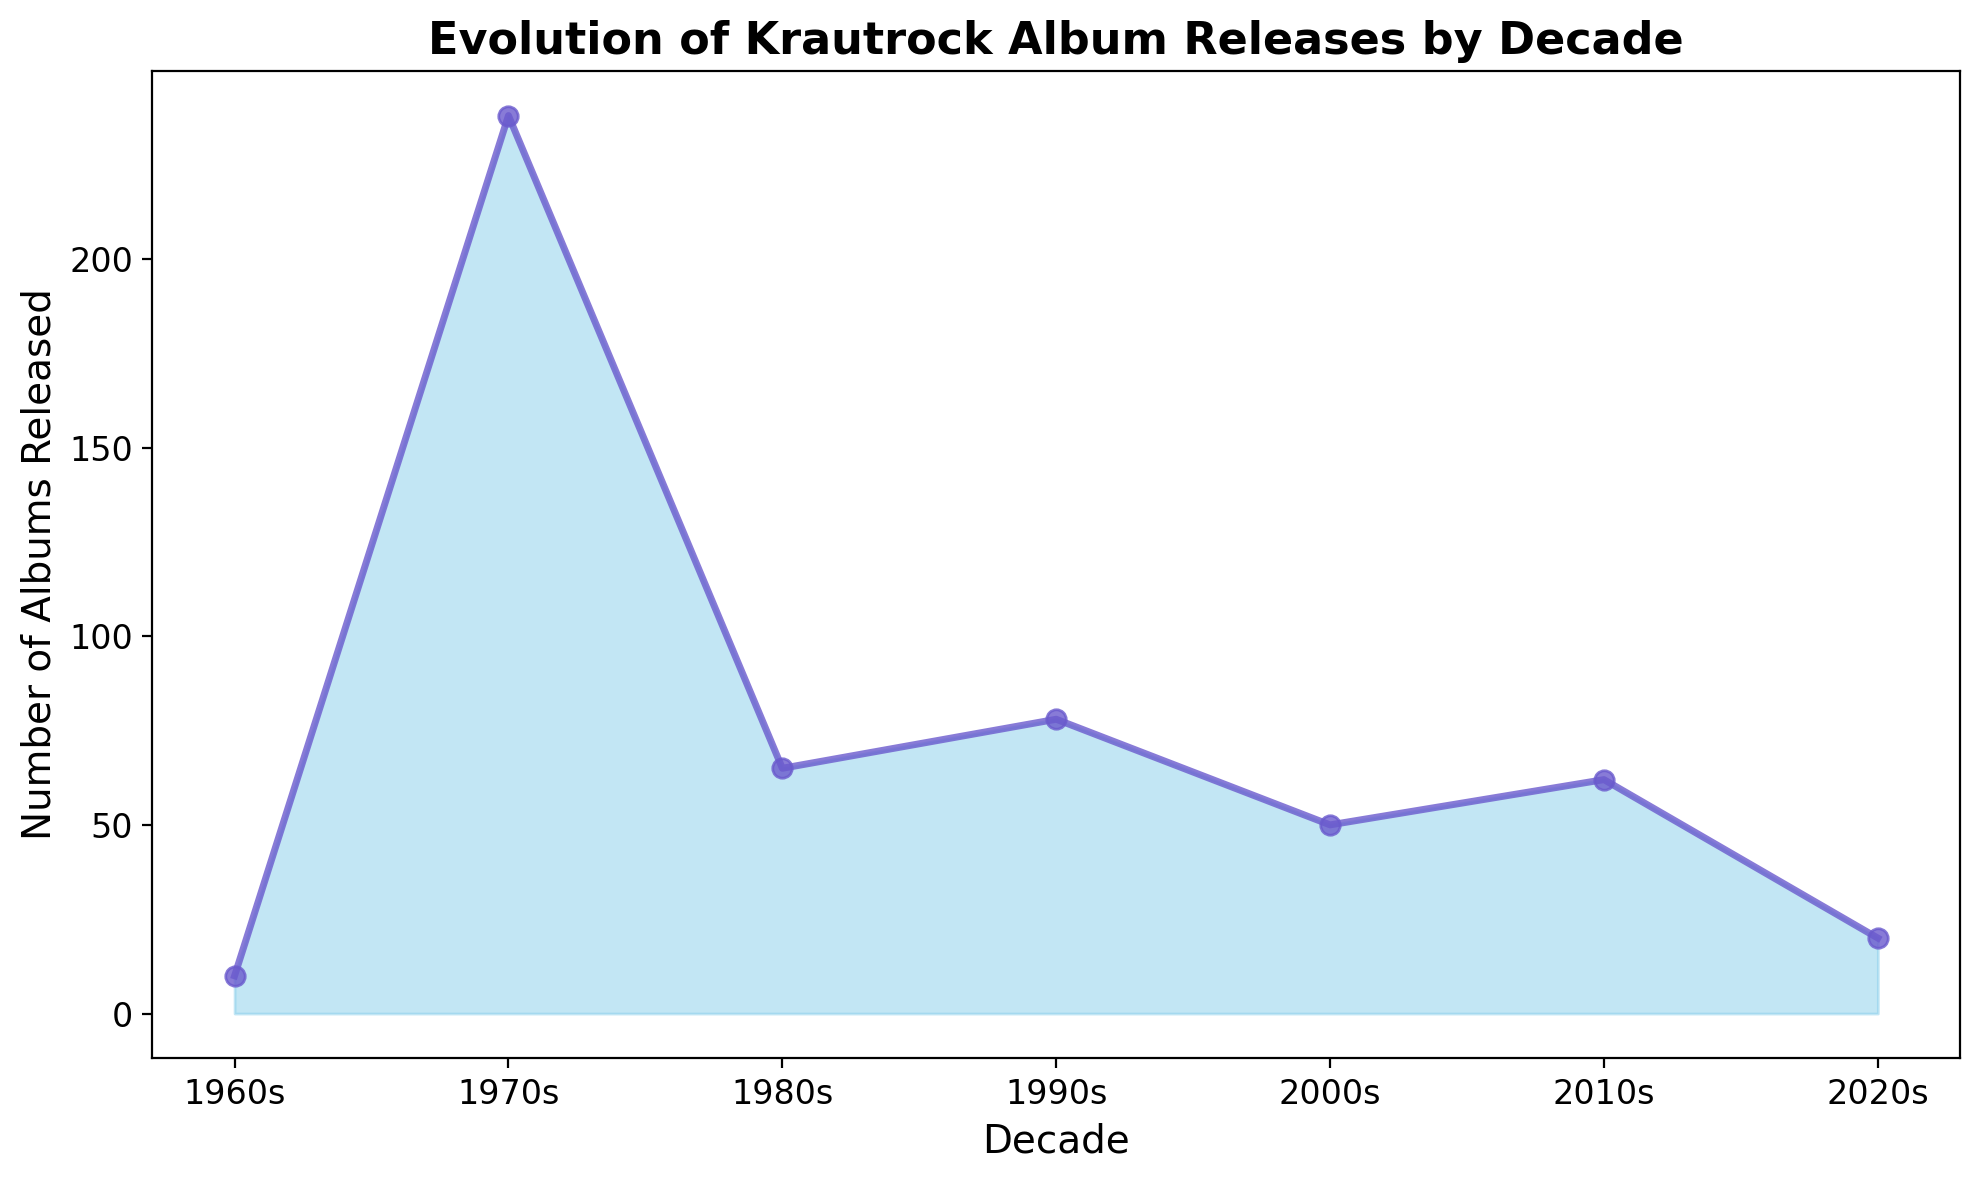What decade saw the highest number of Krautrock album releases? The figure shows that the 1970s had the highest number of album releases because the peak of the area chart is in this decade with 238 albums.
Answer: 1970s What's the difference in album releases between the 1970s and the 1980s? To find the difference, subtract the number of albums released in the 1980s (65) from the number released in the 1970s (238). 238 - 65 = 173
Answer: 173 How many more albums were released in the 1990s compared to the 2000s? Subtract the number of albums released in the 2000s (50) from those in the 1990s (78). 78 - 50 = 28
Answer: 28 What is the trend in album releases from the 2000s to the 2020s? The figure shows a declining trend with album releases decreasing from 50 in the 2000s to 20 in the 2020s.
Answer: Decreasing How many albums were released in the 1960s and 2010s combined? Add the number of albums from the 1960s (10) to those in the 2010s (62). 10 + 62 = 72
Answer: 72 Which decades had fewer than 100 album releases? The figure shows the 1960s, 1980s, 2000s, and 2020s all had album releases below 100.
Answer: 1960s, 1980s, 2000s, 2020s Was there a decade in which Krautrock album releases stayed nearly equal to the previous decade? By examining the figure, the 2010s had 62 releases which are relatively close to the 2000s with 50 releases.
Answer: 2010s How does the height of the area plot change between the 1970s and the 1980s? The height of the area plot drops significantly from the 1970s to the 1980s as the number of album releases decrease from 238 to 65.
Answer: Drops significantly Which two decades had the lowest album releases? The figure shows the lowest album releases are in the 1960s (10) and the 2020s (20).
Answer: 1960s, 2020s What is the approximate midpoint of Krautrock album releases if considering only the counts from the 1980s and 1990s? To find the midpoint (average), add the number of albums in the 1980s (65) and 1990s (78) and divide by 2. (65 + 78) / 2 = 71.5
Answer: 71.5 